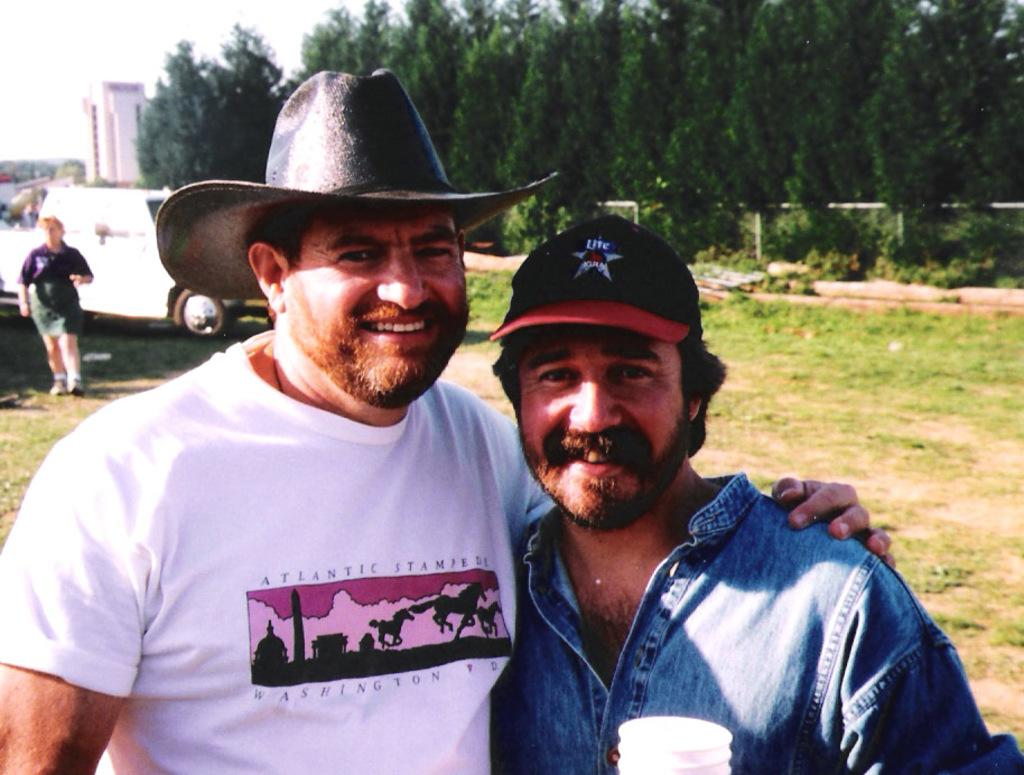How many people are present in the image? There are two people standing in the image. What is the facial expression of the people in the image? The people are smiling. What can be seen in the background of the image? There is a vehicle, a person, and trees in the background of the image. What type of vase is being used to cook on the stove in the image? There is no vase or stove present in the image. How does the person in the background of the image express their pain? There is no indication of pain or any related expression in the image. 